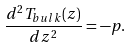<formula> <loc_0><loc_0><loc_500><loc_500>\frac { d ^ { 2 } T _ { b u l k } ( z ) } { d z ^ { 2 } } = - p .</formula> 